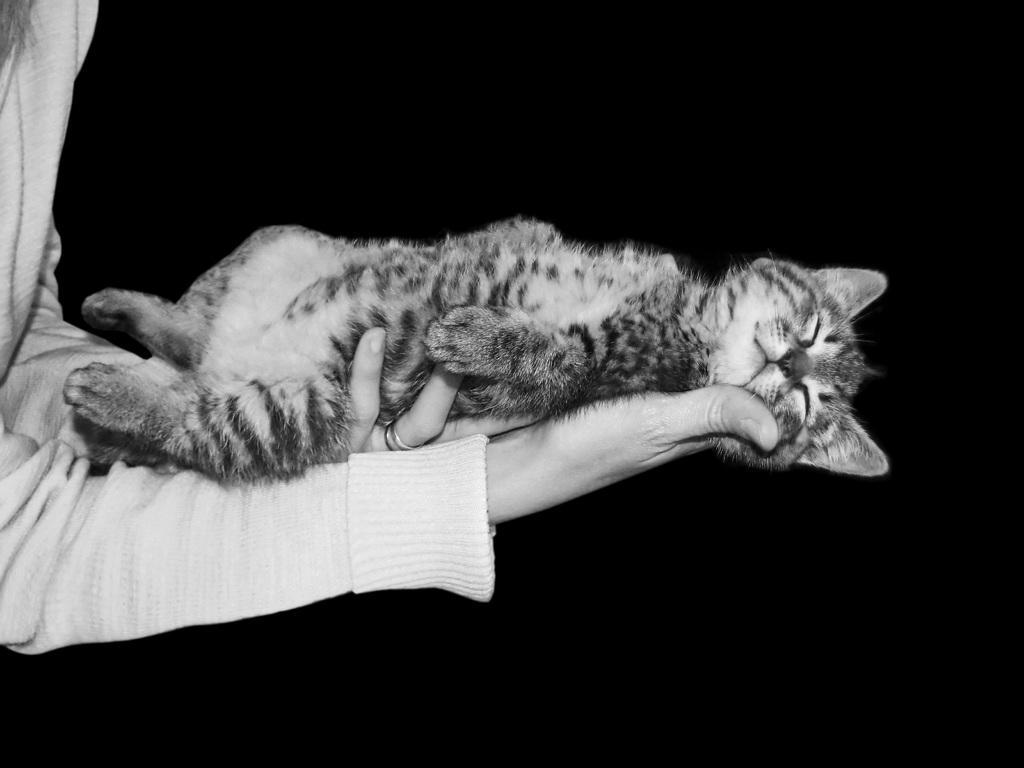Please provide a concise description of this image. In this image there is one person who is holding a cat, and there is a black background. 